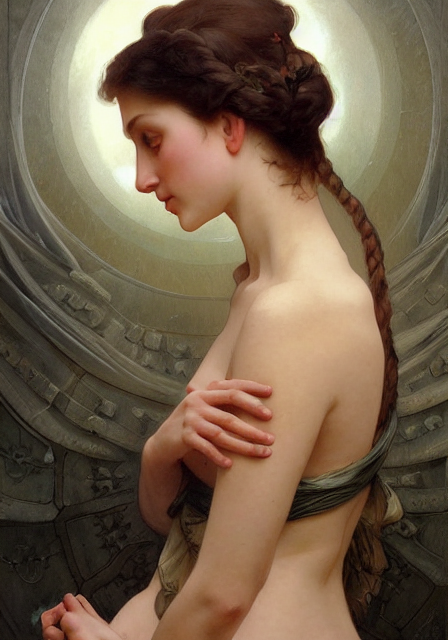How does the choice of colors contribute to the overall mood of the painting? The muted and earthy tones, combined with the use of light and shadow, create a somber yet warm atmosphere that envelops the subject, reinforcing the theme of introspection and the sacred, serene quality of the moment captured. 